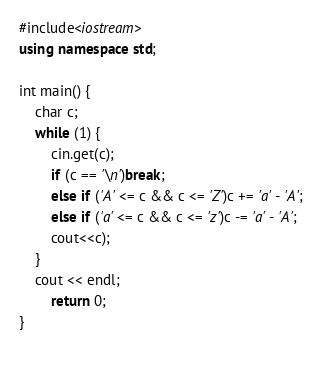Convert code to text. <code><loc_0><loc_0><loc_500><loc_500><_C++_>#include<iostream>
using namespace std;
 
int main() {
    char c;
    while (1) {
        cin.get(c);
        if (c == '\n')break;
        else if ('A' <= c && c <= 'Z')c += 'a' - 'A';
        else if ('a' <= c && c <= 'z')c -= 'a' - 'A';
        cout<<c);
    }
    cout << endl;
        return 0;
}
     </code> 